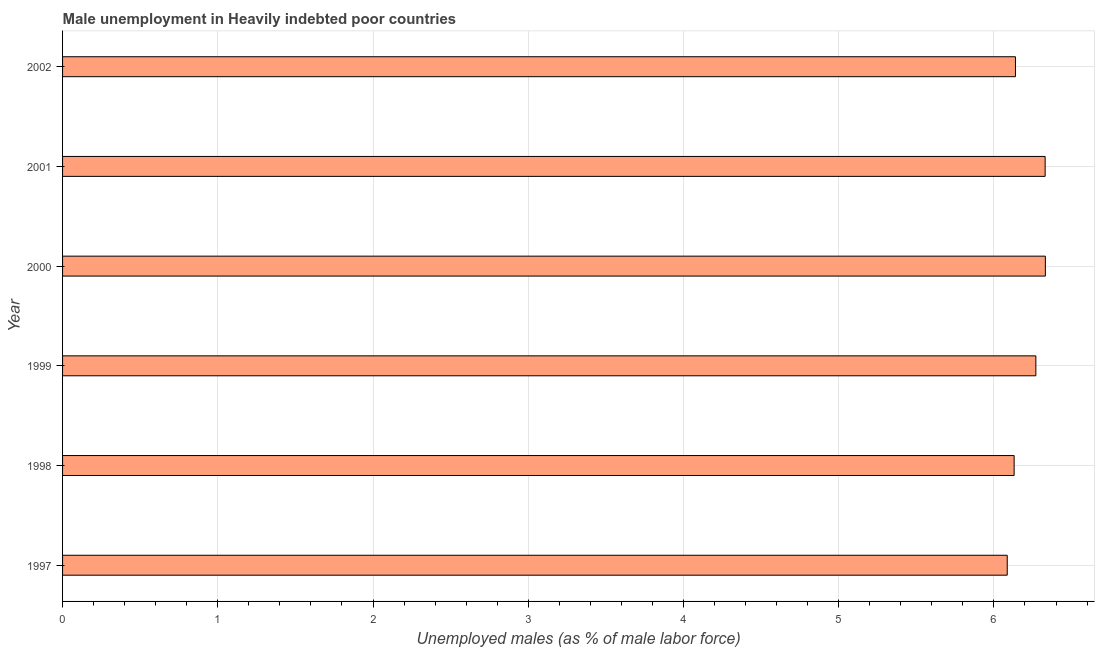What is the title of the graph?
Provide a succinct answer. Male unemployment in Heavily indebted poor countries. What is the label or title of the X-axis?
Your answer should be very brief. Unemployed males (as % of male labor force). What is the unemployed males population in 2000?
Offer a very short reply. 6.33. Across all years, what is the maximum unemployed males population?
Your answer should be very brief. 6.33. Across all years, what is the minimum unemployed males population?
Keep it short and to the point. 6.09. In which year was the unemployed males population maximum?
Give a very brief answer. 2000. What is the sum of the unemployed males population?
Provide a short and direct response. 37.29. What is the difference between the unemployed males population in 2001 and 2002?
Provide a short and direct response. 0.19. What is the average unemployed males population per year?
Provide a short and direct response. 6.21. What is the median unemployed males population?
Provide a succinct answer. 6.2. Do a majority of the years between 1999 and 1997 (inclusive) have unemployed males population greater than 6.4 %?
Offer a very short reply. Yes. Is the unemployed males population in 1999 less than that in 2000?
Provide a short and direct response. Yes. Is the difference between the unemployed males population in 1998 and 2002 greater than the difference between any two years?
Your answer should be very brief. No. How many bars are there?
Your answer should be very brief. 6. What is the difference between two consecutive major ticks on the X-axis?
Provide a short and direct response. 1. Are the values on the major ticks of X-axis written in scientific E-notation?
Keep it short and to the point. No. What is the Unemployed males (as % of male labor force) in 1997?
Offer a very short reply. 6.09. What is the Unemployed males (as % of male labor force) of 1998?
Your response must be concise. 6.13. What is the Unemployed males (as % of male labor force) of 1999?
Ensure brevity in your answer.  6.27. What is the Unemployed males (as % of male labor force) in 2000?
Give a very brief answer. 6.33. What is the Unemployed males (as % of male labor force) in 2001?
Offer a very short reply. 6.33. What is the Unemployed males (as % of male labor force) of 2002?
Offer a very short reply. 6.14. What is the difference between the Unemployed males (as % of male labor force) in 1997 and 1998?
Offer a very short reply. -0.04. What is the difference between the Unemployed males (as % of male labor force) in 1997 and 1999?
Provide a succinct answer. -0.18. What is the difference between the Unemployed males (as % of male labor force) in 1997 and 2000?
Provide a short and direct response. -0.25. What is the difference between the Unemployed males (as % of male labor force) in 1997 and 2001?
Make the answer very short. -0.24. What is the difference between the Unemployed males (as % of male labor force) in 1997 and 2002?
Your answer should be compact. -0.05. What is the difference between the Unemployed males (as % of male labor force) in 1998 and 1999?
Offer a terse response. -0.14. What is the difference between the Unemployed males (as % of male labor force) in 1998 and 2000?
Provide a short and direct response. -0.2. What is the difference between the Unemployed males (as % of male labor force) in 1998 and 2001?
Your answer should be very brief. -0.2. What is the difference between the Unemployed males (as % of male labor force) in 1998 and 2002?
Provide a succinct answer. -0.01. What is the difference between the Unemployed males (as % of male labor force) in 1999 and 2000?
Make the answer very short. -0.06. What is the difference between the Unemployed males (as % of male labor force) in 1999 and 2001?
Offer a terse response. -0.06. What is the difference between the Unemployed males (as % of male labor force) in 1999 and 2002?
Offer a terse response. 0.13. What is the difference between the Unemployed males (as % of male labor force) in 2000 and 2001?
Offer a very short reply. 0. What is the difference between the Unemployed males (as % of male labor force) in 2000 and 2002?
Provide a succinct answer. 0.19. What is the difference between the Unemployed males (as % of male labor force) in 2001 and 2002?
Provide a short and direct response. 0.19. What is the ratio of the Unemployed males (as % of male labor force) in 1997 to that in 1998?
Provide a succinct answer. 0.99. What is the ratio of the Unemployed males (as % of male labor force) in 1997 to that in 2001?
Keep it short and to the point. 0.96. What is the ratio of the Unemployed males (as % of male labor force) in 1997 to that in 2002?
Give a very brief answer. 0.99. What is the ratio of the Unemployed males (as % of male labor force) in 1998 to that in 2000?
Your answer should be very brief. 0.97. What is the ratio of the Unemployed males (as % of male labor force) in 1998 to that in 2001?
Your answer should be very brief. 0.97. What is the ratio of the Unemployed males (as % of male labor force) in 1998 to that in 2002?
Ensure brevity in your answer.  1. What is the ratio of the Unemployed males (as % of male labor force) in 1999 to that in 2001?
Your answer should be very brief. 0.99. What is the ratio of the Unemployed males (as % of male labor force) in 2000 to that in 2001?
Ensure brevity in your answer.  1. What is the ratio of the Unemployed males (as % of male labor force) in 2000 to that in 2002?
Ensure brevity in your answer.  1.03. What is the ratio of the Unemployed males (as % of male labor force) in 2001 to that in 2002?
Your response must be concise. 1.03. 